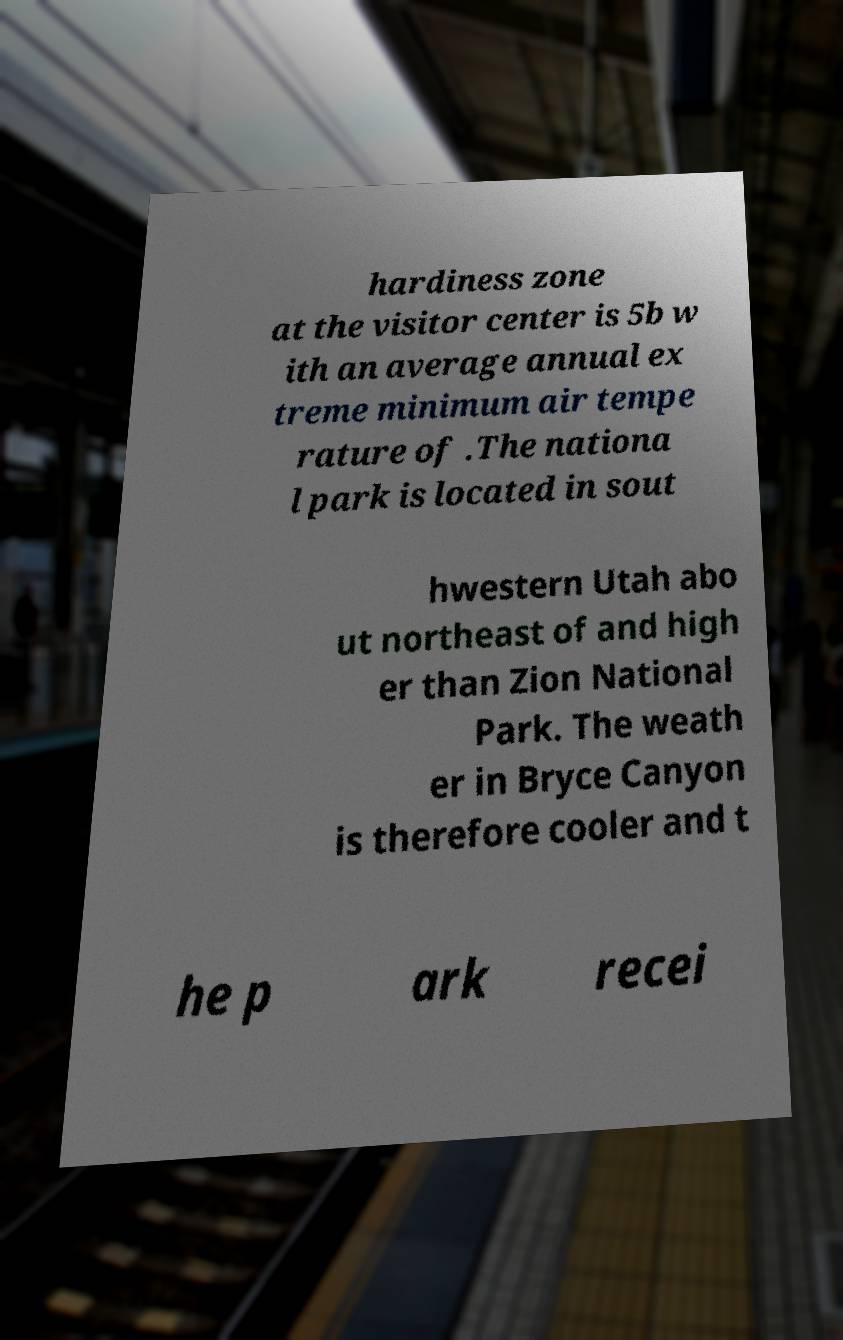Can you accurately transcribe the text from the provided image for me? hardiness zone at the visitor center is 5b w ith an average annual ex treme minimum air tempe rature of .The nationa l park is located in sout hwestern Utah abo ut northeast of and high er than Zion National Park. The weath er in Bryce Canyon is therefore cooler and t he p ark recei 